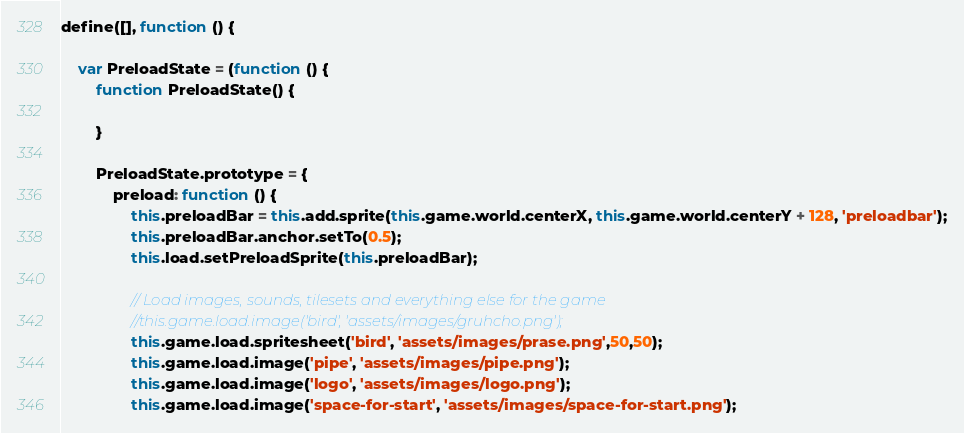Convert code to text. <code><loc_0><loc_0><loc_500><loc_500><_JavaScript_>define([], function () {

    var PreloadState = (function () {
        function PreloadState() {

        }

        PreloadState.prototype = {
            preload: function () {
                this.preloadBar = this.add.sprite(this.game.world.centerX, this.game.world.centerY + 128, 'preloadbar');
                this.preloadBar.anchor.setTo(0.5);
                this.load.setPreloadSprite(this.preloadBar);

                // Load images, sounds, tilesets and everything else for the game
                //this.game.load.image('bird', 'assets/images/gruhcho.png');
                this.game.load.spritesheet('bird', 'assets/images/prase.png',50,50);
                this.game.load.image('pipe', 'assets/images/pipe.png');
                this.game.load.image('logo', 'assets/images/logo.png');
                this.game.load.image('space-for-start', 'assets/images/space-for-start.png');</code> 